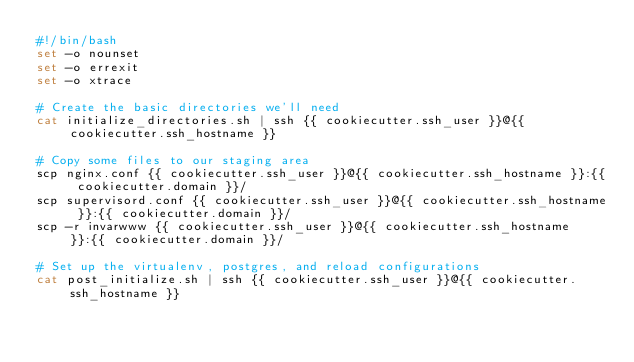Convert code to text. <code><loc_0><loc_0><loc_500><loc_500><_Bash_>#!/bin/bash
set -o nounset
set -o errexit
set -o xtrace

# Create the basic directories we'll need
cat initialize_directories.sh | ssh {{ cookiecutter.ssh_user }}@{{ cookiecutter.ssh_hostname }}

# Copy some files to our staging area
scp nginx.conf {{ cookiecutter.ssh_user }}@{{ cookiecutter.ssh_hostname }}:{{ cookiecutter.domain }}/
scp supervisord.conf {{ cookiecutter.ssh_user }}@{{ cookiecutter.ssh_hostname }}:{{ cookiecutter.domain }}/
scp -r invarwww {{ cookiecutter.ssh_user }}@{{ cookiecutter.ssh_hostname }}:{{ cookiecutter.domain }}/

# Set up the virtualenv, postgres, and reload configurations
cat post_initialize.sh | ssh {{ cookiecutter.ssh_user }}@{{ cookiecutter.ssh_hostname }}
</code> 